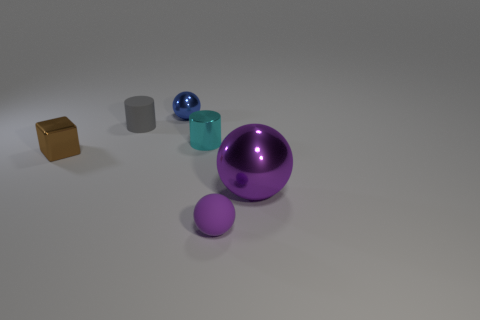There is a thing that is both on the left side of the large purple thing and to the right of the cyan object; what is its color?
Offer a very short reply. Purple. Are there any rubber balls that have the same color as the large thing?
Keep it short and to the point. Yes. The metal thing that is behind the small rubber cylinder is what color?
Ensure brevity in your answer.  Blue. Is there a tiny ball in front of the metallic thing that is on the left side of the matte cylinder?
Offer a very short reply. Yes. Does the tiny matte sphere have the same color as the shiny thing that is in front of the brown metallic object?
Provide a short and direct response. Yes. Are there any small cyan cylinders that have the same material as the blue ball?
Ensure brevity in your answer.  Yes. What number of objects are there?
Your answer should be compact. 6. What is the ball to the left of the small sphere in front of the block made of?
Provide a short and direct response. Metal. What is the color of the other tiny thing that is made of the same material as the small purple thing?
Your response must be concise. Gray. There is a gray thing left of the blue ball; does it have the same size as the rubber thing on the right side of the matte cylinder?
Ensure brevity in your answer.  Yes. 